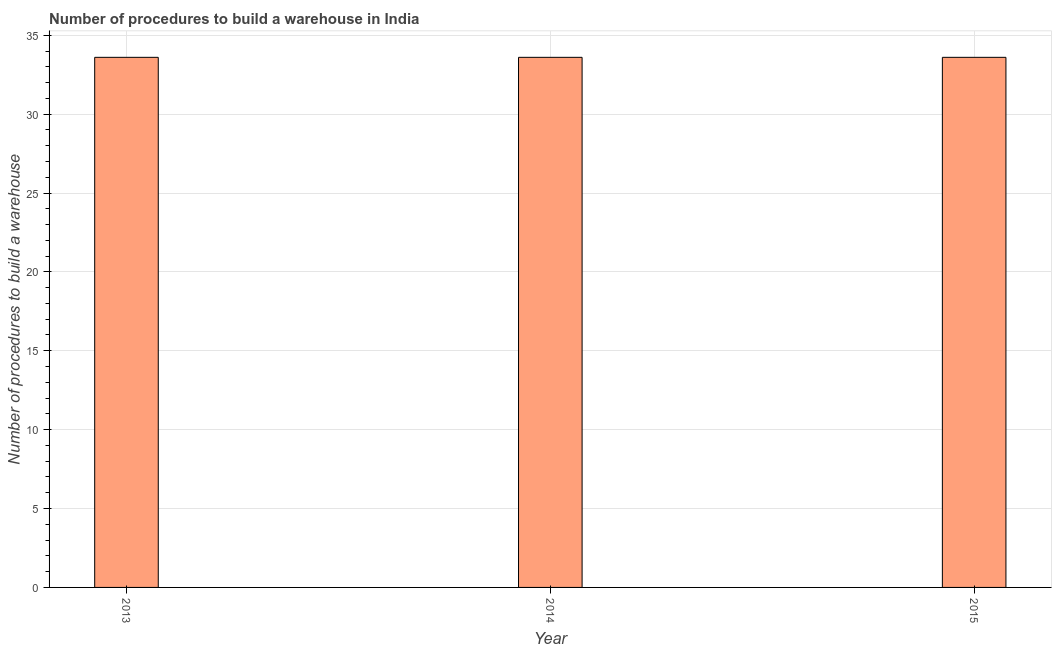What is the title of the graph?
Ensure brevity in your answer.  Number of procedures to build a warehouse in India. What is the label or title of the Y-axis?
Ensure brevity in your answer.  Number of procedures to build a warehouse. What is the number of procedures to build a warehouse in 2013?
Give a very brief answer. 33.6. Across all years, what is the maximum number of procedures to build a warehouse?
Give a very brief answer. 33.6. Across all years, what is the minimum number of procedures to build a warehouse?
Provide a short and direct response. 33.6. In which year was the number of procedures to build a warehouse maximum?
Give a very brief answer. 2013. What is the sum of the number of procedures to build a warehouse?
Provide a succinct answer. 100.8. What is the average number of procedures to build a warehouse per year?
Offer a very short reply. 33.6. What is the median number of procedures to build a warehouse?
Make the answer very short. 33.6. In how many years, is the number of procedures to build a warehouse greater than 11 ?
Offer a terse response. 3. What is the ratio of the number of procedures to build a warehouse in 2013 to that in 2014?
Give a very brief answer. 1. Is the difference between the number of procedures to build a warehouse in 2013 and 2014 greater than the difference between any two years?
Make the answer very short. Yes. What is the difference between the highest and the second highest number of procedures to build a warehouse?
Offer a very short reply. 0. In how many years, is the number of procedures to build a warehouse greater than the average number of procedures to build a warehouse taken over all years?
Ensure brevity in your answer.  0. How many bars are there?
Your response must be concise. 3. What is the difference between two consecutive major ticks on the Y-axis?
Offer a terse response. 5. Are the values on the major ticks of Y-axis written in scientific E-notation?
Keep it short and to the point. No. What is the Number of procedures to build a warehouse in 2013?
Offer a terse response. 33.6. What is the Number of procedures to build a warehouse of 2014?
Your response must be concise. 33.6. What is the Number of procedures to build a warehouse of 2015?
Provide a succinct answer. 33.6. What is the difference between the Number of procedures to build a warehouse in 2013 and 2014?
Your answer should be very brief. 0. What is the ratio of the Number of procedures to build a warehouse in 2013 to that in 2015?
Offer a very short reply. 1. What is the ratio of the Number of procedures to build a warehouse in 2014 to that in 2015?
Make the answer very short. 1. 